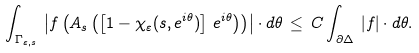Convert formula to latex. <formula><loc_0><loc_0><loc_500><loc_500>\int _ { \Gamma _ { \varepsilon , s } } \, \left | f \left ( A _ { s } \left ( \left [ 1 - \chi _ { \varepsilon } ( s , e ^ { i \theta } ) \right ] \, e ^ { i \theta } \right ) \right ) \right | \cdot d \theta \, \leq \, C \int _ { \partial \Delta } \, | f | \cdot d \theta .</formula> 